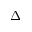<formula> <loc_0><loc_0><loc_500><loc_500>\Delta</formula> 